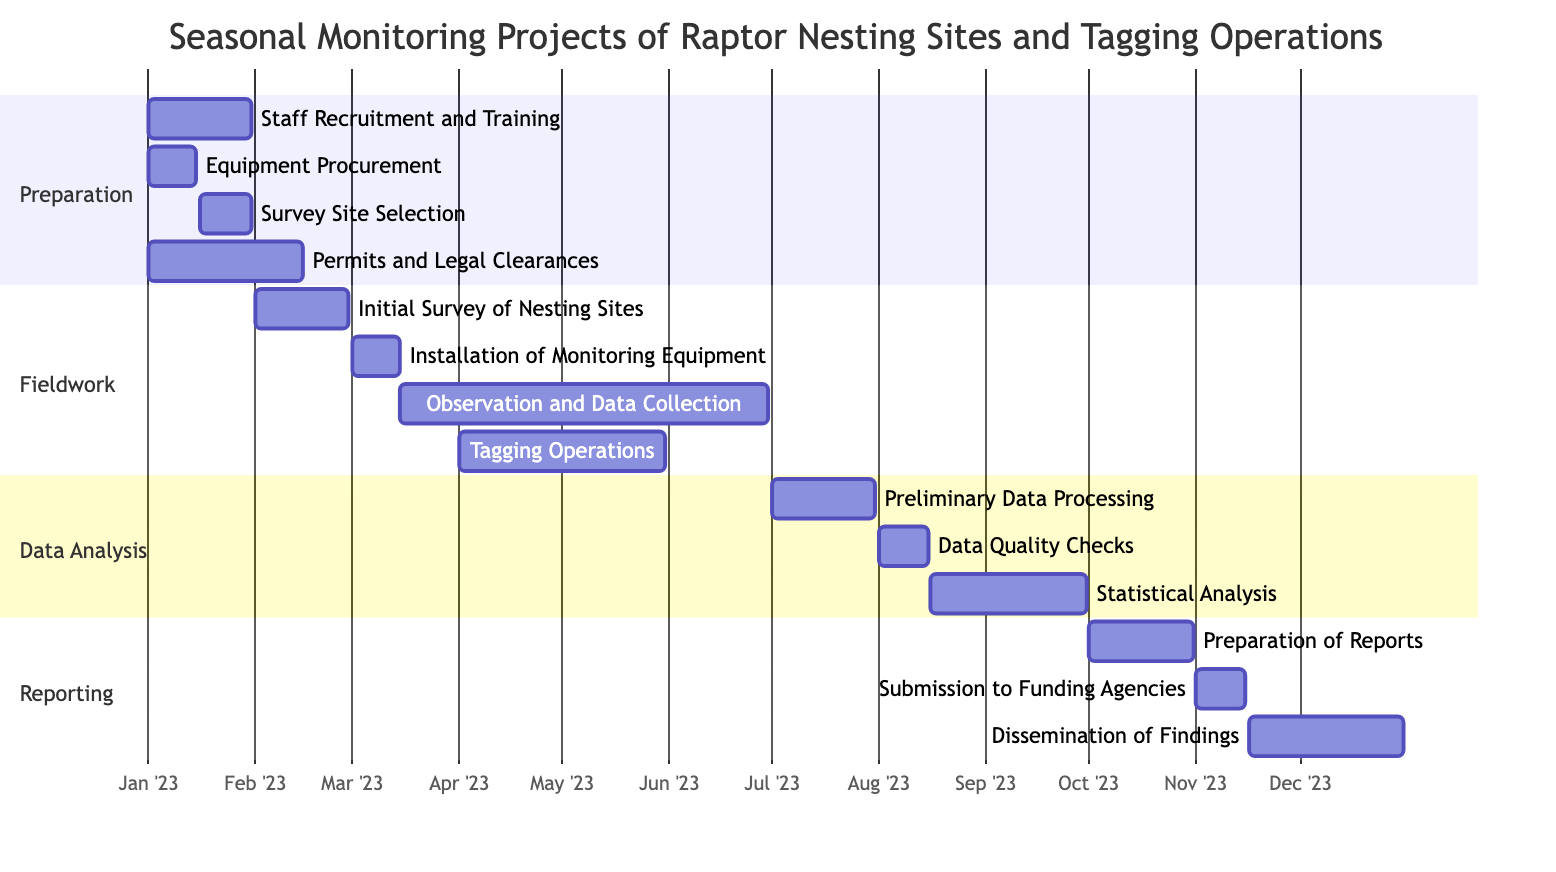What is the total duration of the "Preparation" phase? The "Preparation" phase starts on January 1, 2023, and ends on February 15, 2023. To calculate the duration, we determine the number of days between these two dates, which amounts to 46 days.
Answer: 46 days Which task overlaps with both "Observation and Data Collection" and "Tagging Operations"? The "Observation and Data Collection" task runs from March 15, 2023, to June 30, 2023, and "Tagging Operations" runs from April 1, 2023, to May 31, 2023. The overlap occurs from April 1, 2023, to May 31, 2023.
Answer: Tagging Operations How many tasks are scheduled in the "Data Analysis" phase? In the "Data Analysis" phase, there are three tasks: "Preliminary Data Processing," "Data Quality Checks," and "Statistical Analysis." Counting these tasks gives a total of three.
Answer: 3 What is the start date of the "Submission to Funding Agencies" task? The "Submission to Funding Agencies" task starts on November 1, 2023. This date can be found by locating this task in the "Reporting" phase.
Answer: November 1, 2023 Which phase has the longest duration in this project? To find the phase with the longest duration, we calculate the duration of each phase: "Preparation" lasts 46 days, "Fieldwork" lasts 107 days (February 1 to June 30), "Data Analysis" lasts 91 days (July 1 to September 30), and "Reporting" lasts 62 days (October 1 to December 31). By comparison, the longest phase is "Fieldwork."
Answer: Fieldwork When does data collection begin and end? The "Observation and Data Collection" task starts on March 15, 2023, and ends on June 30, 2023. This is obtained from the timeline of the "Fieldwork" section.
Answer: March 15, 2023 to June 30, 2023 What activity follows "Data Quality Checks"? "Data Quality Checks" concludes on August 15, 2023. The subsequent activity listed is "Statistical Analysis," which begins the next day on August 16, 2023.
Answer: Statistical Analysis Which task is scheduled immediately after the "Installation of Monitoring Equipment"? The "Installation of Monitoring Equipment" task ends on March 15, 2023. The task that follows it immediately is "Observation and Data Collection," which starts the same day, March 15, 2023.
Answer: Observation and Data Collection 